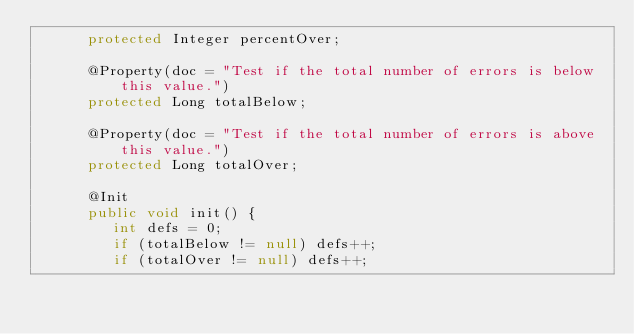<code> <loc_0><loc_0><loc_500><loc_500><_Java_>      protected Integer percentOver;

      @Property(doc = "Test if the total number of errors is below this value.")
      protected Long totalBelow;

      @Property(doc = "Test if the total number of errors is above this value.")
      protected Long totalOver;

      @Init
      public void init() {
         int defs = 0;
         if (totalBelow != null) defs++;
         if (totalOver != null) defs++;</code> 